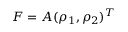Convert formula to latex. <formula><loc_0><loc_0><loc_500><loc_500>F = A ( \rho _ { 1 } , \rho _ { 2 } ) ^ { T }</formula> 